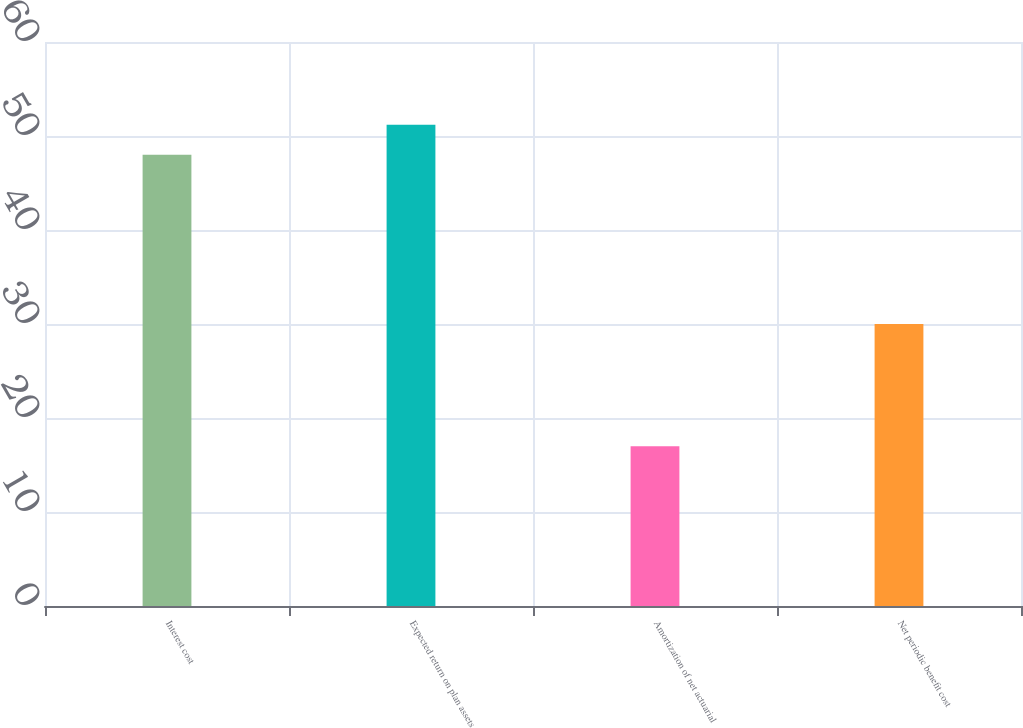<chart> <loc_0><loc_0><loc_500><loc_500><bar_chart><fcel>Interest cost<fcel>Expected return on plan assets<fcel>Amortization of net actuarial<fcel>Net periodic benefit cost<nl><fcel>48<fcel>51.2<fcel>17<fcel>30<nl></chart> 